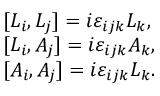Convert formula to latex. <formula><loc_0><loc_0><loc_500><loc_500>\begin{array} { l } { { [ L _ { i } , L _ { j } ] = i \varepsilon _ { i j k } L _ { k } , } } \\ { { { [ } L _ { i } , A _ { j } ] = i \varepsilon _ { i j k } A _ { k } , } } \\ { { { [ } A _ { i } , A _ { j } ] = i \varepsilon _ { i j k } L _ { k } . } } \end{array}</formula> 